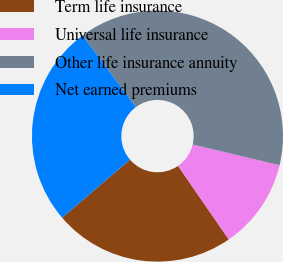Convert chart. <chart><loc_0><loc_0><loc_500><loc_500><pie_chart><fcel>Term life insurance<fcel>Universal life insurance<fcel>Other life insurance annuity<fcel>Net earned premiums<nl><fcel>23.35%<fcel>11.67%<fcel>38.91%<fcel>26.07%<nl></chart> 